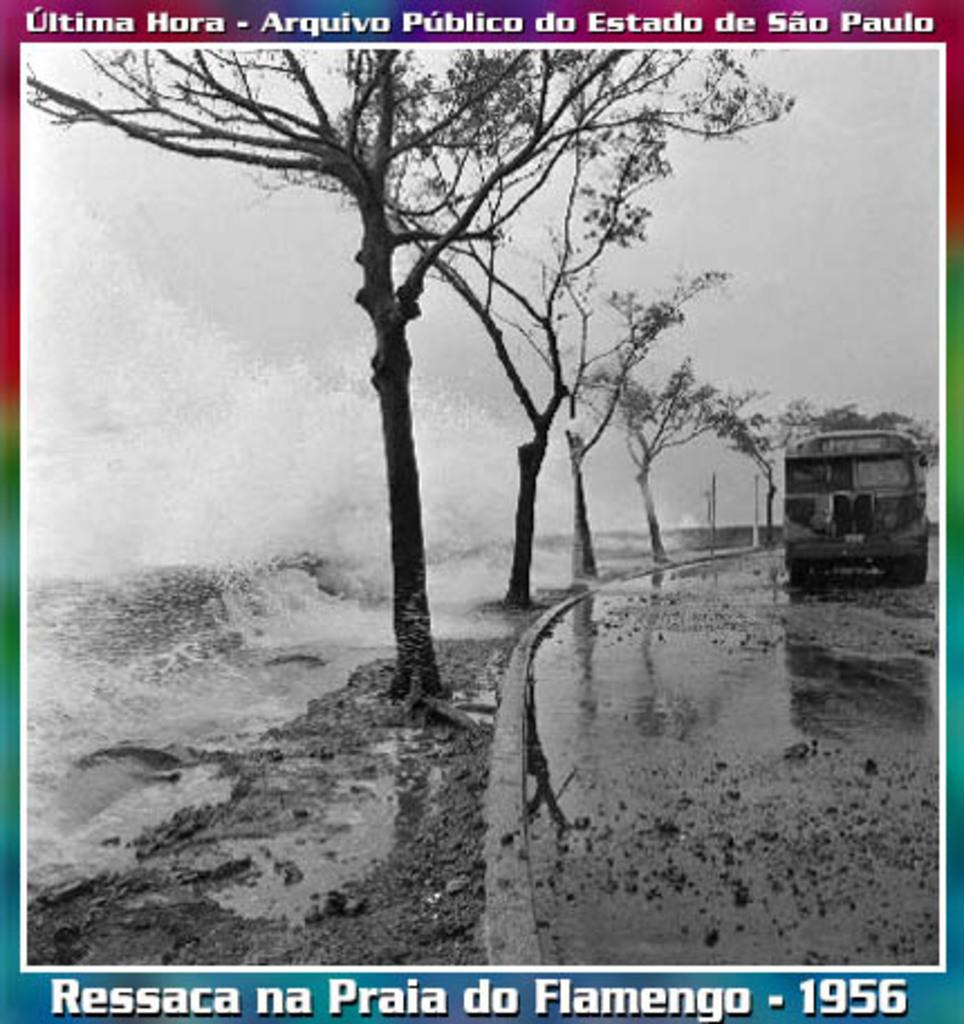What year was this photo taken?
Offer a very short reply. 1956. Where was this picture taken?
Offer a very short reply. Sao paulo. 